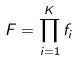Convert formula to latex. <formula><loc_0><loc_0><loc_500><loc_500>F = \prod _ { i = 1 } ^ { K } f _ { i }</formula> 